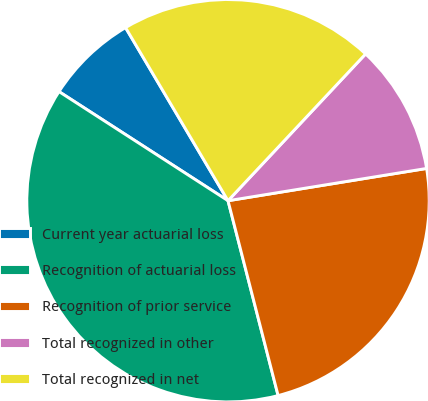<chart> <loc_0><loc_0><loc_500><loc_500><pie_chart><fcel>Current year actuarial loss<fcel>Recognition of actuarial loss<fcel>Recognition of prior service<fcel>Total recognized in other<fcel>Total recognized in net<nl><fcel>7.37%<fcel>38.13%<fcel>23.56%<fcel>10.45%<fcel>20.49%<nl></chart> 